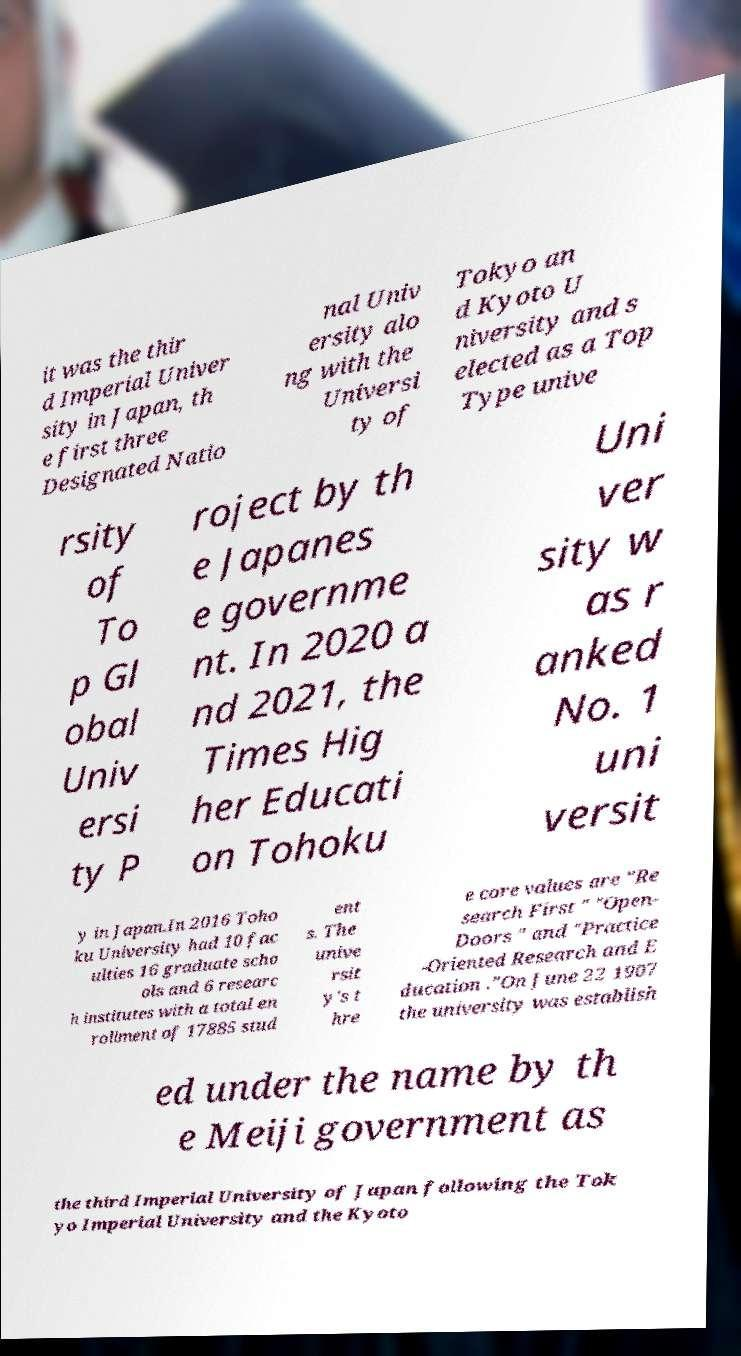I need the written content from this picture converted into text. Can you do that? it was the thir d Imperial Univer sity in Japan, th e first three Designated Natio nal Univ ersity alo ng with the Universi ty of Tokyo an d Kyoto U niversity and s elected as a Top Type unive rsity of To p Gl obal Univ ersi ty P roject by th e Japanes e governme nt. In 2020 a nd 2021, the Times Hig her Educati on Tohoku Uni ver sity w as r anked No. 1 uni versit y in Japan.In 2016 Toho ku University had 10 fac ulties 16 graduate scho ols and 6 researc h institutes with a total en rollment of 17885 stud ent s. The unive rsit y's t hre e core values are "Re search First " "Open- Doors " and "Practice -Oriented Research and E ducation ."On June 22 1907 the university was establish ed under the name by th e Meiji government as the third Imperial University of Japan following the Tok yo Imperial University and the Kyoto 